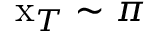Convert formula to latex. <formula><loc_0><loc_0><loc_500><loc_500>x _ { T } \sim \pi</formula> 